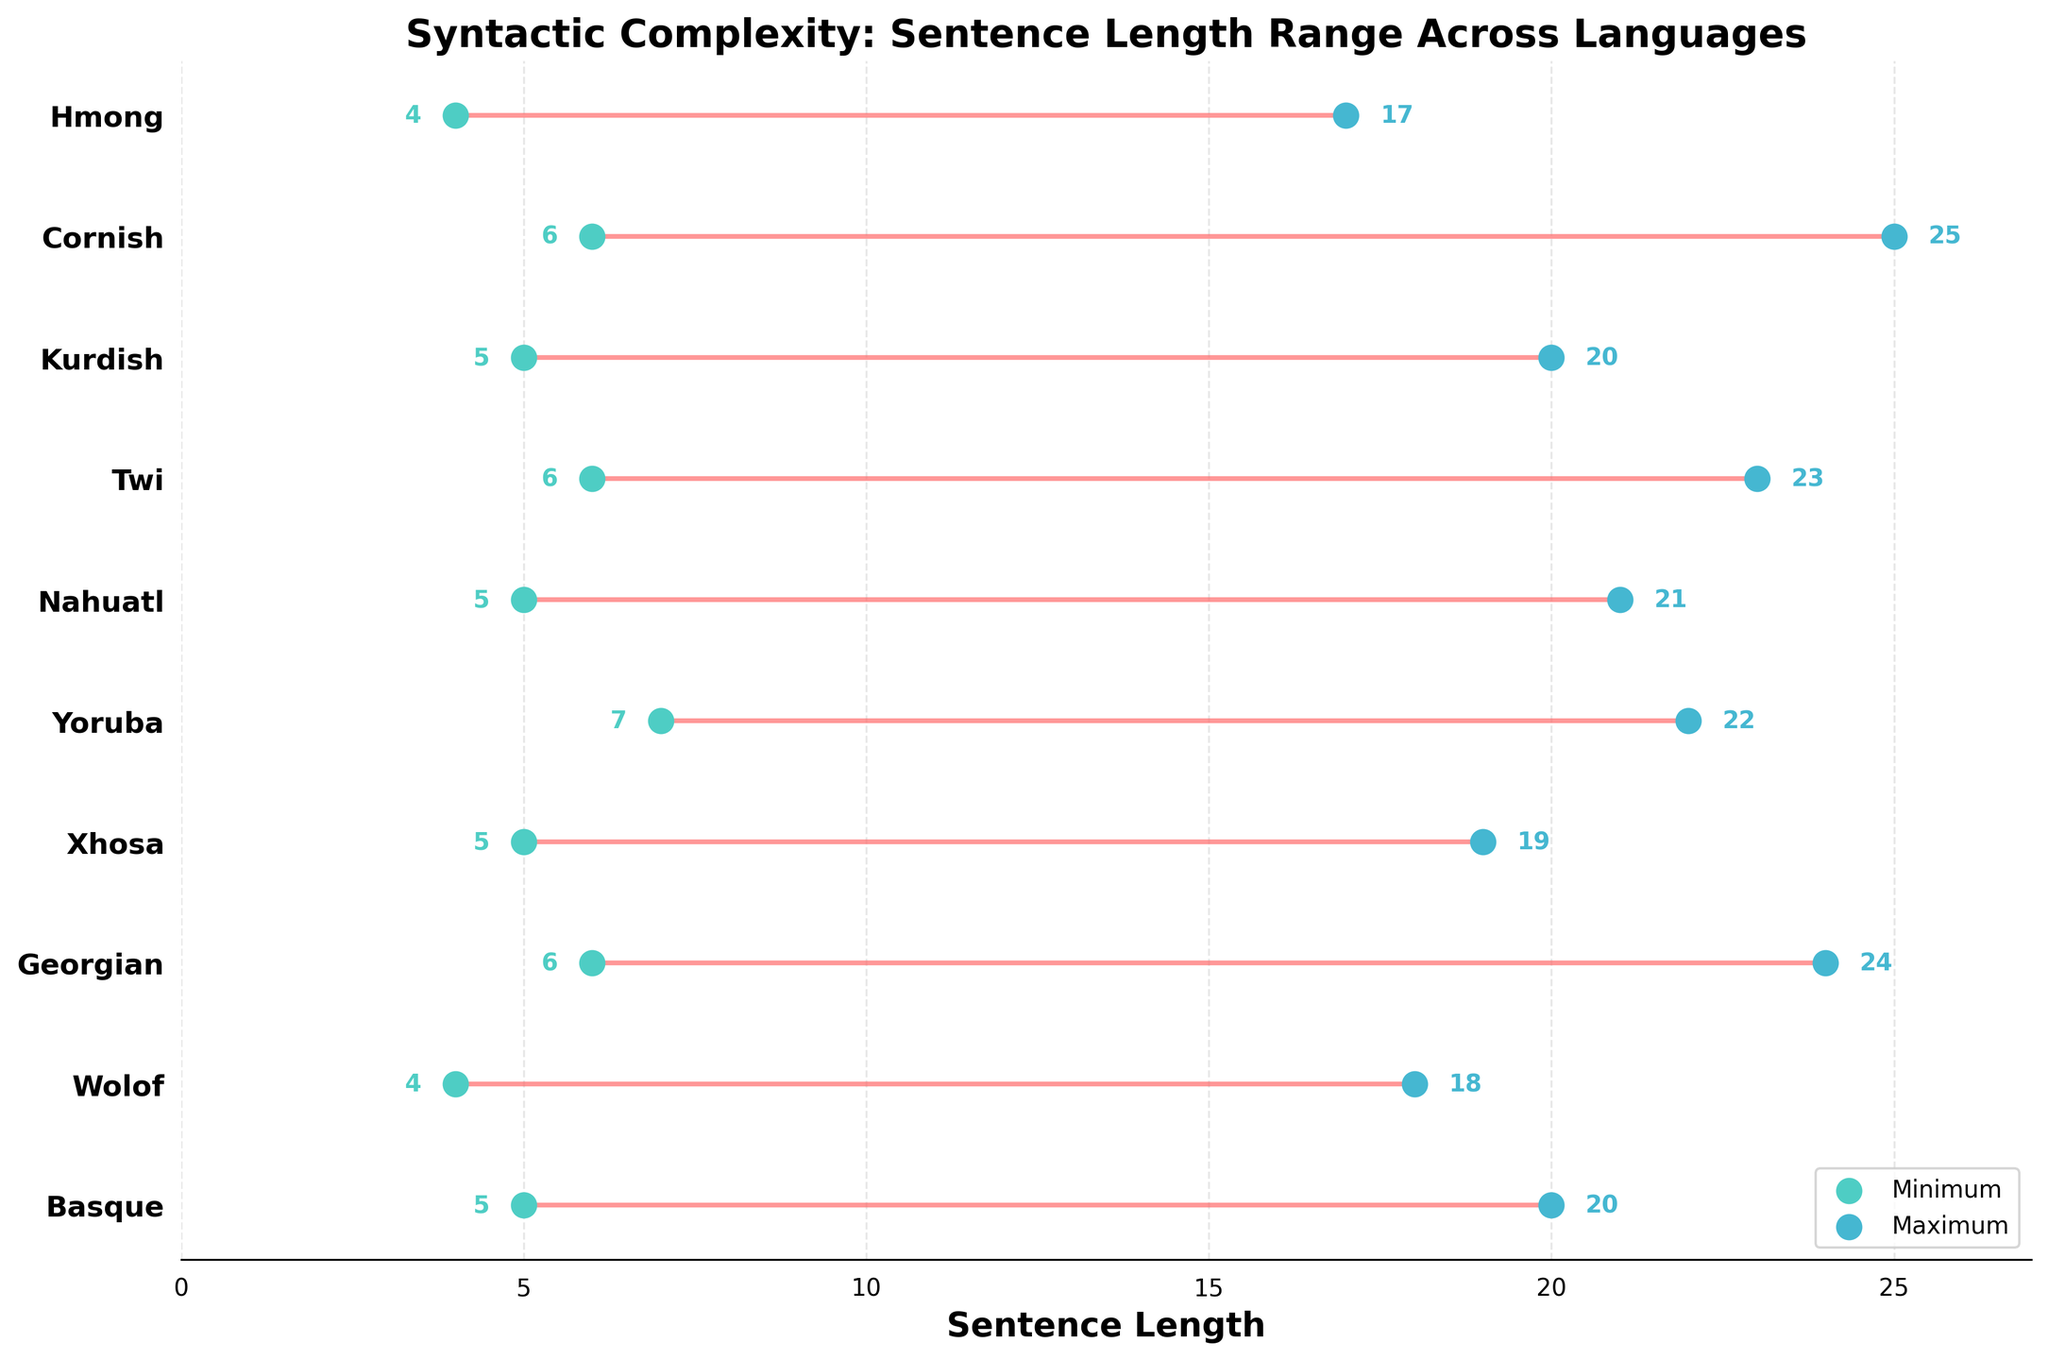Which language has the minimum sentence length of 4? By looking at the horizontal position of the dot labeled 'Minimum' and finding the corresponding language on the y-axis, we see that Wolof and Hmong have a minimum sentence length of 4.
Answer: Wolof, Hmong Which language has the greatest range between minimum and maximum sentence lengths? To determine the language with the greatest range, subtract the minimum sentence lengths from the maximum sentence lengths for each language, then identify the largest difference. Cornish has the greatest range (25 - 6 = 19).
Answer: Cornish What is the average maximum sentence length across all languages? Sum all the maximum sentence lengths and divide by the number of languages. (20 + 18 + 24 + 19 + 22 + 21 + 23 + 20 + 25 + 17) / 10 = 209 / 10 = 20.9
Answer: 20.9 Which languages have a minimum sentence length of 6? Identify the languages that have the dot labeled 'Minimum' positioned at 6 along the sentence length axis. Georgian, Twi, and Cornish meet this criterion.
Answer: Georgian, Twi, Cornish Do any languages have equal minimum and maximum sentence lengths? Look for any languages where the dots labeled 'Minimum' and 'Maximum' are at the same horizontal position. No languages have equal minimum and maximum sentence lengths.
Answer: No Is there any language with a maximum sentence length greater than 23? Identify if any language’s maximum sentence dot exceeds the value of 23 on the sentence length axis. Cornish has a maximum sentence length of 25.
Answer: Cornish What is the average range of sentence lengths for Basque and Yoruba? Calculate the range for Basque (20 - 5 = 15) and Yoruba (22 - 7 = 15), then find the average (15 + 15) / 2 = 15.
Answer: 15 How many languages have a minimum sentence length of 5? Count the number of dots labeled 'Minimum' at the position of 5 along the sentence length axis. Basque, Xhosa, Nahuatl, and Kurdish meet this criterion.
Answer: 4 Which language has the shortest maximum sentence length? Compare the position of the dots labeled 'Maximum' along the sentence length axis to identify the shortest maximum sentence length. Hmong has the shortest at 17.
Answer: Hmong 